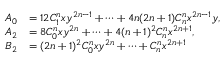Convert formula to latex. <formula><loc_0><loc_0><loc_500><loc_500>\begin{array} { r l } { A _ { 0 } } & { = 1 2 C _ { 1 } ^ { n } x y ^ { 2 n - 1 } + \cdots + 4 n ( 2 n + 1 ) C _ { n } ^ { n } x ^ { 2 n - 1 } y , } \\ { A _ { 2 } } & { = 8 C _ { 0 } ^ { n } x y ^ { 2 n } + \cdots + 4 ( n + 1 ) ^ { 2 } C _ { n } ^ { n } x ^ { 2 n + 1 } , } \\ { B _ { 2 } } & { = ( 2 n + 1 ) ^ { 2 } C _ { 0 } ^ { n } x y ^ { 2 n } + \cdots + C _ { n } ^ { n } x ^ { 2 n + 1 } } \end{array}</formula> 